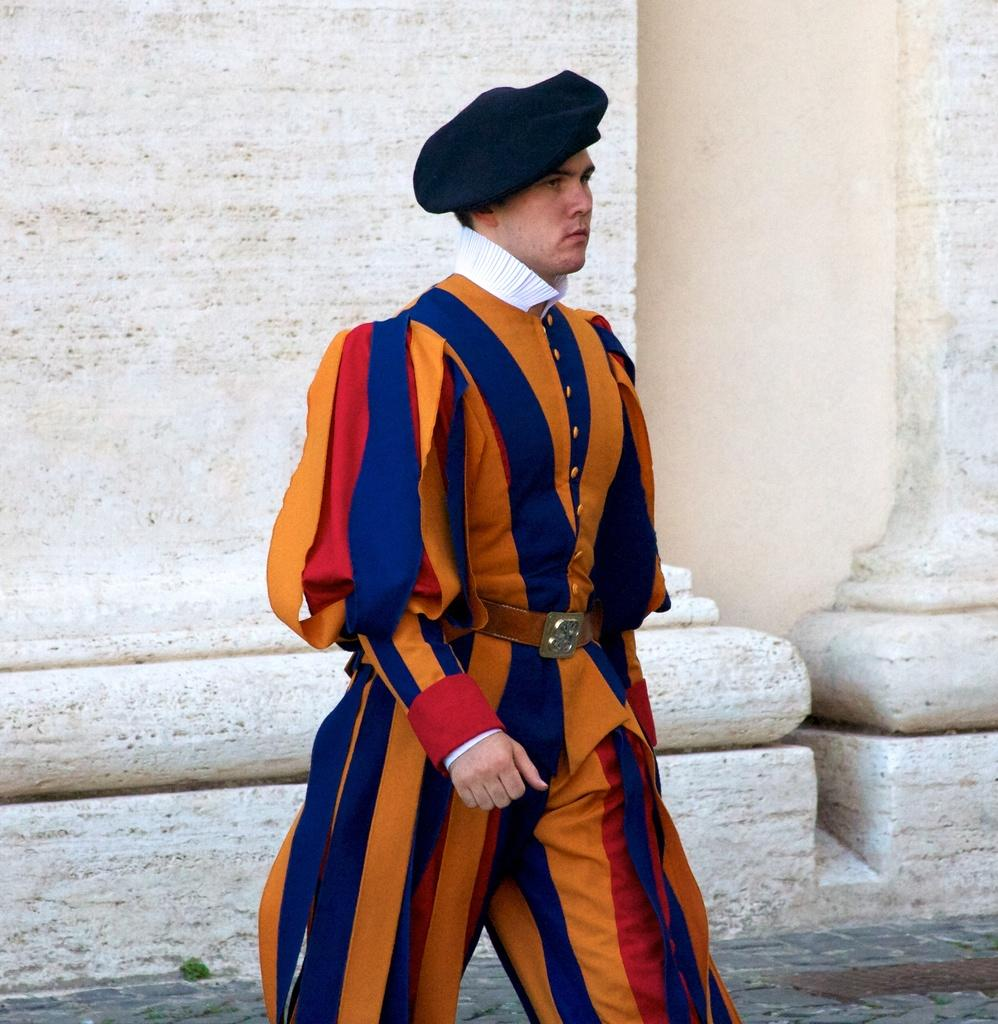Who or what is present in the image? There is a person in the image. What is the person wearing on their head? The person is wearing a cap on their head. What can be seen in the background of the image? There are pillars visible in the background of the image. What type of mountain can be seen in the background of the image? There is no mountain present in the background of the image; it features pillars instead. What season is depicted in the image, considering the person's attire? The person's attire does not indicate a specific season, as caps can be worn in various seasons. 